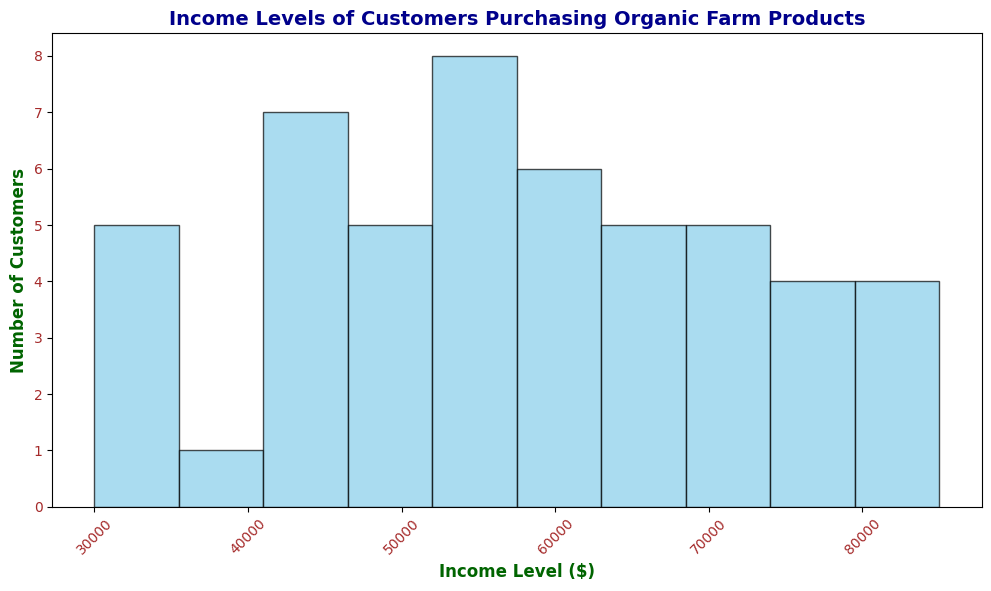What's the income level range for the most common number of customers? Look at the tallest bar in the histogram. The x-axis range that this bar covers represents the income level range of the most common number of customers.
Answer: 50,000-60,000 Which income range has the least number of customers? Look at the shortest bar(s) in the histogram. Identify the x-axis range that corresponds to this bar.
Answer: 80,000-90,000 How many customers have an income level between $40,000 and $50,000? Identify the height of the bar that corresponds to the income range of $40,000 to $50,000 by checking the y-axis value.
Answer: 6 What is the most significant difference in customer counts between two adjacent income ranges? Compare the heights of adjacent bars and find the two with the largest difference. Calculate the difference in their heights.
Answer: The range $50,000-$60,000 and $60,000-$70,000, difference is 8-6 = 2 Which income level ranges have exactly five customers each? Find bars with a height of 5 on the y-axis and note their corresponding x-axis income level ranges.
Answer: 70,000-80,000 What is the total number of customers in the $30,000 to $60,000 income range? Sum the heights of all bars from $30,000 to $40,000, $40,000 to $50,000, and $50,000 to $60,000. (5 + 6 + 8) = 19
Answer: 19 Between which two income ranges do you observe the biggest drop in the number of customers? Observe the differences between the heights of adjacent bars and identify where the maximum reduction occurs. The biggest drop occurs from 8 to 6 customers when moving from the $50,000-$60,000 range to the $60,000-$70,000 range.
Answer: $50,000-$60,000 to $60,000-$70,000 What's the median income level of the customers? Since the dataset comprises 50 customers, the median income level lies between the 25th and 26th highest income values. Both lie in the same bar because it’s sorted. Refer to the histogram and find the median range which shows the customer's income is $60,000.
Answer: $50,000-$60,000 